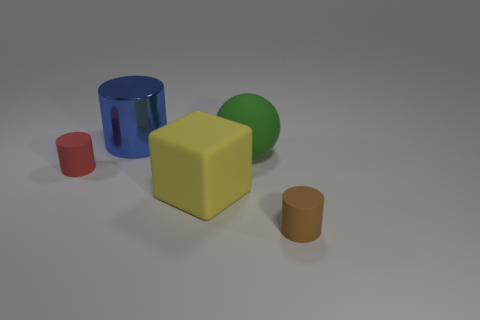Can you tell if these objects are associated with a particular activity? Given their simplicity and varied shapes, these objects could be tools for a basic educational activity, perhaps serving to teach shapes and colors to children. They might also be used in sorting or stacking games that emphasize size differentiation and color recognition. 